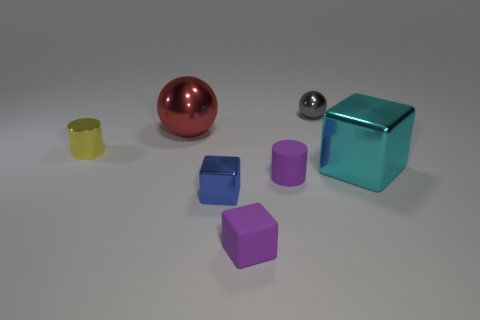Subtract all matte cubes. How many cubes are left? 2 Add 2 yellow objects. How many objects exist? 9 Subtract all spheres. How many objects are left? 5 Subtract 1 blocks. How many blocks are left? 2 Subtract all cyan cubes. How many yellow cylinders are left? 1 Subtract all shiny cubes. Subtract all metal spheres. How many objects are left? 3 Add 1 purple rubber cylinders. How many purple rubber cylinders are left? 2 Add 6 metallic spheres. How many metallic spheres exist? 8 Subtract all purple cubes. How many cubes are left? 2 Subtract 1 gray spheres. How many objects are left? 6 